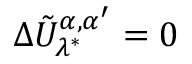Convert formula to latex. <formula><loc_0><loc_0><loc_500><loc_500>\Delta \tilde { U } _ { \lambda ^ { * } } ^ { \alpha , \alpha ^ { \prime } } = 0</formula> 